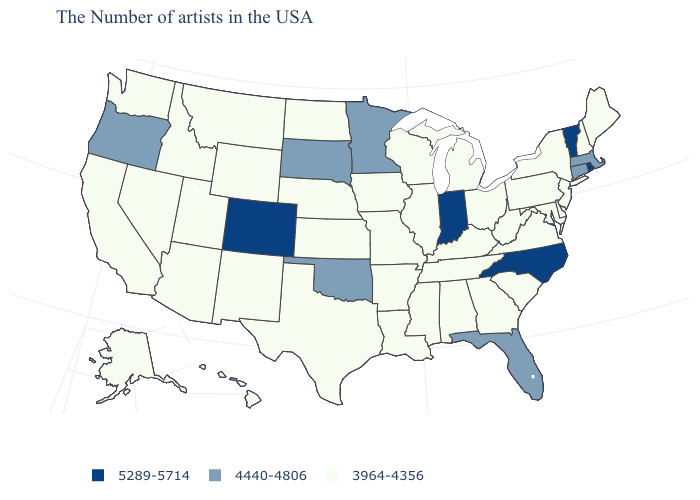Among the states that border Wyoming , does Utah have the lowest value?
Quick response, please. Yes. Does Indiana have the highest value in the MidWest?
Short answer required. Yes. What is the value of Connecticut?
Be succinct. 4440-4806. Does Colorado have the same value as Indiana?
Answer briefly. Yes. Does New Mexico have the same value as Maine?
Keep it brief. Yes. Which states have the lowest value in the West?
Answer briefly. Wyoming, New Mexico, Utah, Montana, Arizona, Idaho, Nevada, California, Washington, Alaska, Hawaii. How many symbols are there in the legend?
Answer briefly. 3. What is the value of Hawaii?
Keep it brief. 3964-4356. What is the lowest value in states that border Arkansas?
Quick response, please. 3964-4356. What is the lowest value in the USA?
Concise answer only. 3964-4356. What is the highest value in the USA?
Quick response, please. 5289-5714. Name the states that have a value in the range 3964-4356?
Concise answer only. Maine, New Hampshire, New York, New Jersey, Delaware, Maryland, Pennsylvania, Virginia, South Carolina, West Virginia, Ohio, Georgia, Michigan, Kentucky, Alabama, Tennessee, Wisconsin, Illinois, Mississippi, Louisiana, Missouri, Arkansas, Iowa, Kansas, Nebraska, Texas, North Dakota, Wyoming, New Mexico, Utah, Montana, Arizona, Idaho, Nevada, California, Washington, Alaska, Hawaii. Name the states that have a value in the range 5289-5714?
Short answer required. Rhode Island, Vermont, North Carolina, Indiana, Colorado. Name the states that have a value in the range 5289-5714?
Quick response, please. Rhode Island, Vermont, North Carolina, Indiana, Colorado. 